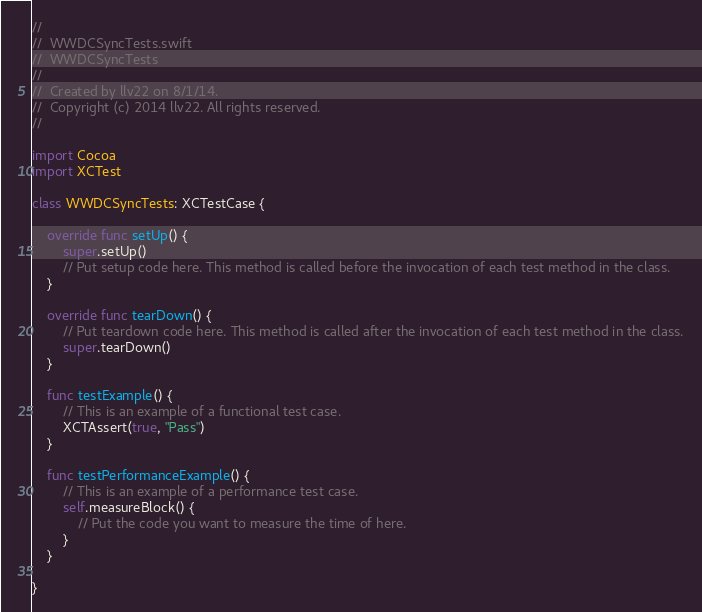Convert code to text. <code><loc_0><loc_0><loc_500><loc_500><_Swift_>//
//  WWDCSyncTests.swift
//  WWDCSyncTests
//
//  Created by llv22 on 8/1/14.
//  Copyright (c) 2014 llv22. All rights reserved.
//

import Cocoa
import XCTest

class WWDCSyncTests: XCTestCase {
    
    override func setUp() {
        super.setUp()
        // Put setup code here. This method is called before the invocation of each test method in the class.
    }
    
    override func tearDown() {
        // Put teardown code here. This method is called after the invocation of each test method in the class.
        super.tearDown()
    }
    
    func testExample() {
        // This is an example of a functional test case.
        XCTAssert(true, "Pass")
    }
    
    func testPerformanceExample() {
        // This is an example of a performance test case.
        self.measureBlock() {
            // Put the code you want to measure the time of here.
        }
    }
    
}
</code> 